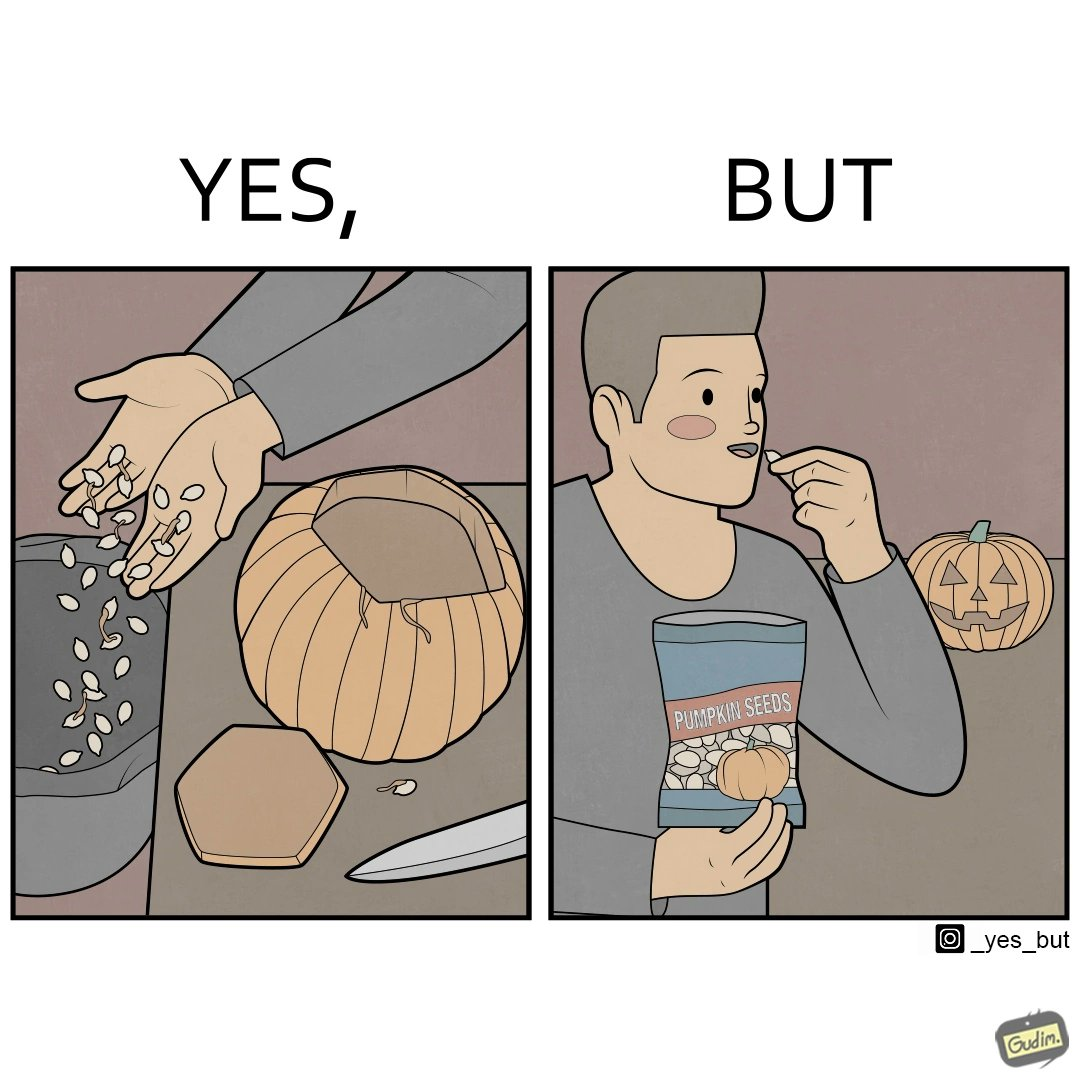Explain why this image is satirical. The image is ironic, because on one side the same person throws pumpkin seeds out of pumpkin into dustbin when brought at home but he is eating the package pumpkin seeds 